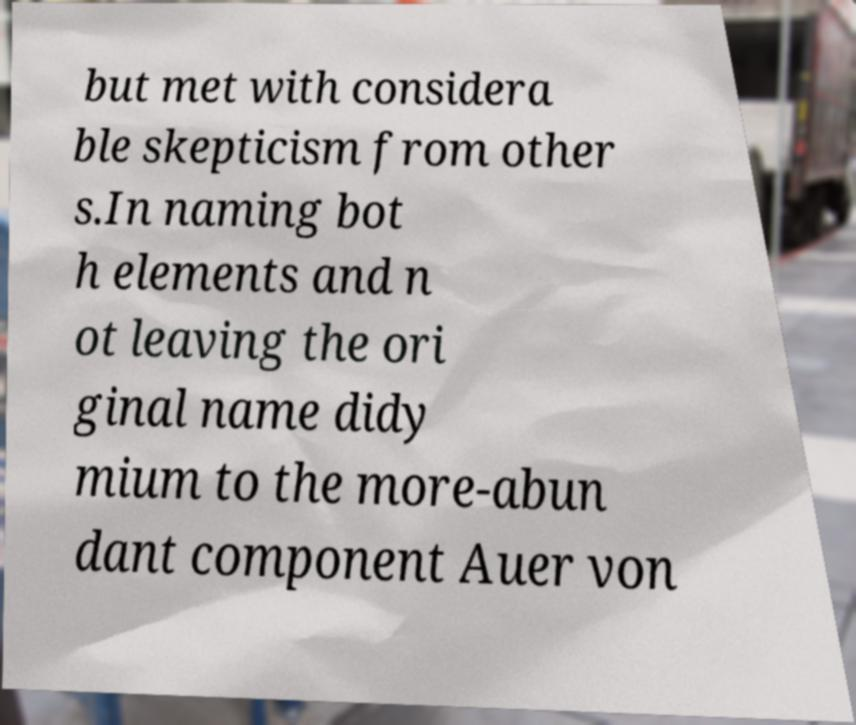For documentation purposes, I need the text within this image transcribed. Could you provide that? but met with considera ble skepticism from other s.In naming bot h elements and n ot leaving the ori ginal name didy mium to the more-abun dant component Auer von 